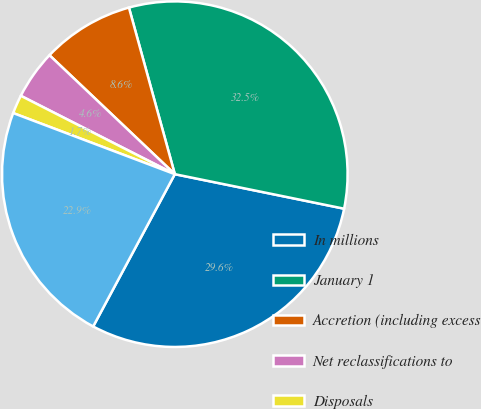<chart> <loc_0><loc_0><loc_500><loc_500><pie_chart><fcel>In millions<fcel>January 1<fcel>Accretion (including excess<fcel>Net reclassifications to<fcel>Disposals<fcel>December 31<nl><fcel>29.63%<fcel>32.48%<fcel>8.64%<fcel>4.59%<fcel>1.74%<fcel>22.92%<nl></chart> 